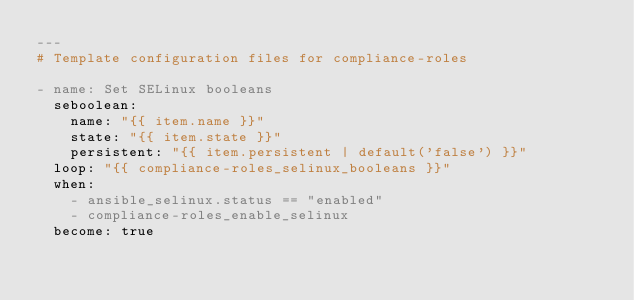Convert code to text. <code><loc_0><loc_0><loc_500><loc_500><_YAML_>---
# Template configuration files for compliance-roles

- name: Set SELinux booleans
  seboolean:
    name: "{{ item.name }}"
    state: "{{ item.state }}"
    persistent: "{{ item.persistent | default('false') }}"
  loop: "{{ compliance-roles_selinux_booleans }}"
  when:
    - ansible_selinux.status == "enabled"
    - compliance-roles_enable_selinux
  become: true
</code> 